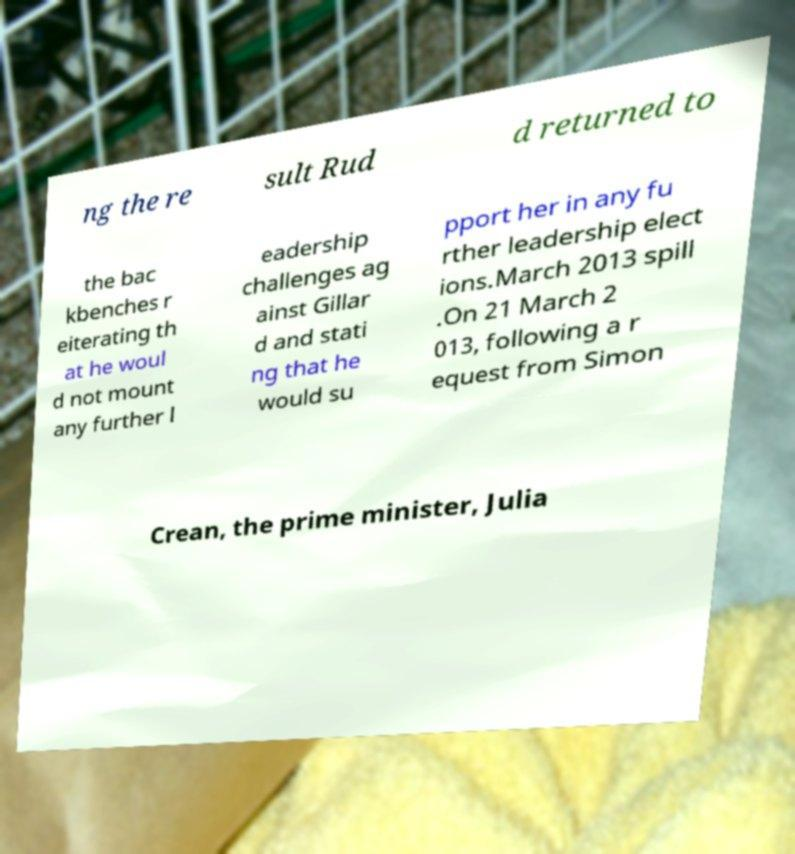Can you read and provide the text displayed in the image?This photo seems to have some interesting text. Can you extract and type it out for me? ng the re sult Rud d returned to the bac kbenches r eiterating th at he woul d not mount any further l eadership challenges ag ainst Gillar d and stati ng that he would su pport her in any fu rther leadership elect ions.March 2013 spill .On 21 March 2 013, following a r equest from Simon Crean, the prime minister, Julia 